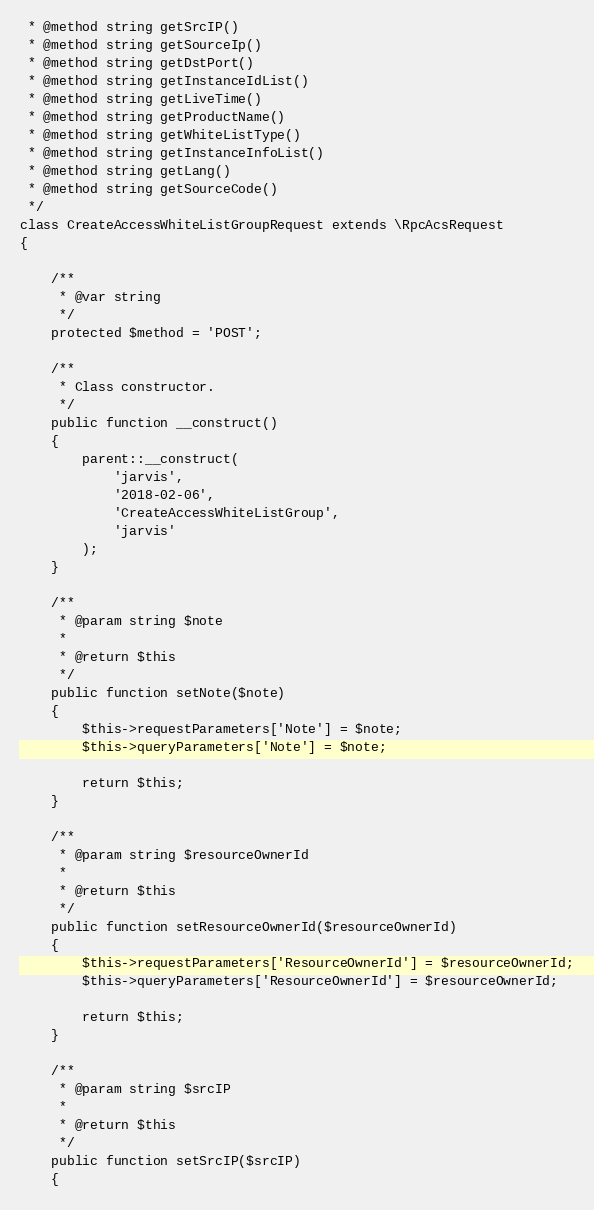Convert code to text. <code><loc_0><loc_0><loc_500><loc_500><_PHP_> * @method string getSrcIP()
 * @method string getSourceIp()
 * @method string getDstPort()
 * @method string getInstanceIdList()
 * @method string getLiveTime()
 * @method string getProductName()
 * @method string getWhiteListType()
 * @method string getInstanceInfoList()
 * @method string getLang()
 * @method string getSourceCode()
 */
class CreateAccessWhiteListGroupRequest extends \RpcAcsRequest
{

    /**
     * @var string
     */
    protected $method = 'POST';

    /**
     * Class constructor.
     */
    public function __construct()
    {
        parent::__construct(
            'jarvis',
            '2018-02-06',
            'CreateAccessWhiteListGroup',
            'jarvis'
        );
    }

    /**
     * @param string $note
     *
     * @return $this
     */
    public function setNote($note)
    {
        $this->requestParameters['Note'] = $note;
        $this->queryParameters['Note'] = $note;

        return $this;
    }

    /**
     * @param string $resourceOwnerId
     *
     * @return $this
     */
    public function setResourceOwnerId($resourceOwnerId)
    {
        $this->requestParameters['ResourceOwnerId'] = $resourceOwnerId;
        $this->queryParameters['ResourceOwnerId'] = $resourceOwnerId;

        return $this;
    }

    /**
     * @param string $srcIP
     *
     * @return $this
     */
    public function setSrcIP($srcIP)
    {</code> 